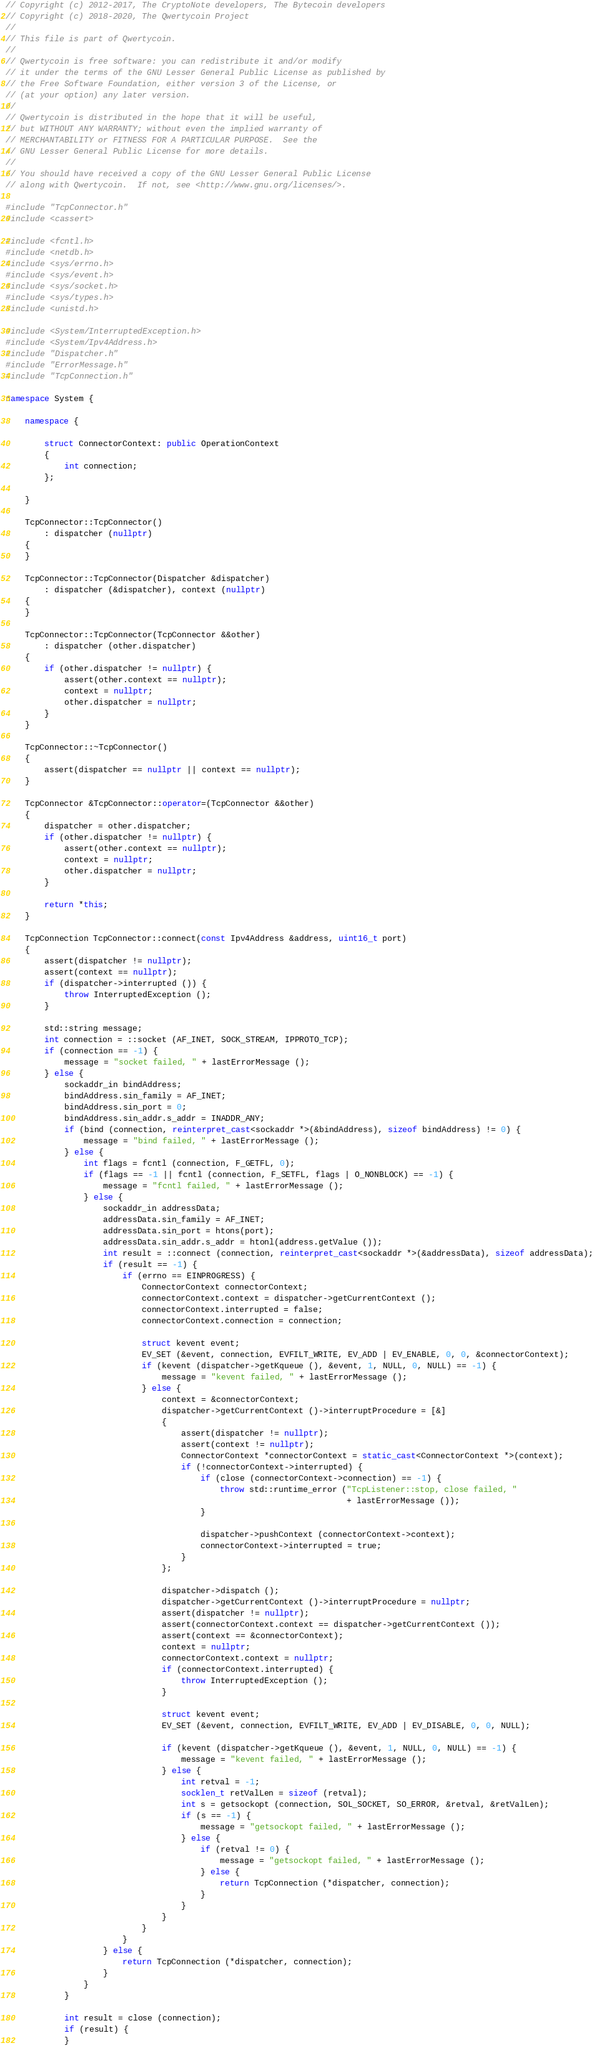<code> <loc_0><loc_0><loc_500><loc_500><_C++_>// Copyright (c) 2012-2017, The CryptoNote developers, The Bytecoin developers
// Copyright (c) 2018-2020, The Qwertycoin Project
//
// This file is part of Qwertycoin.
//
// Qwertycoin is free software: you can redistribute it and/or modify
// it under the terms of the GNU Lesser General Public License as published by
// the Free Software Foundation, either version 3 of the License, or
// (at your option) any later version.
//
// Qwertycoin is distributed in the hope that it will be useful,
// but WITHOUT ANY WARRANTY; without even the implied warranty of
// MERCHANTABILITY or FITNESS FOR A PARTICULAR PURPOSE.  See the
// GNU Lesser General Public License for more details.
//
// You should have received a copy of the GNU Lesser General Public License
// along with Qwertycoin.  If not, see <http://www.gnu.org/licenses/>.

#include "TcpConnector.h"
#include <cassert>

#include <fcntl.h>
#include <netdb.h>
#include <sys/errno.h>
#include <sys/event.h>
#include <sys/socket.h>
#include <sys/types.h>
#include <unistd.h>

#include <System/InterruptedException.h>
#include <System/Ipv4Address.h>
#include "Dispatcher.h"
#include "ErrorMessage.h"
#include "TcpConnection.h"

namespace System {

    namespace {

        struct ConnectorContext: public OperationContext
        {
            int connection;
        };

    }

    TcpConnector::TcpConnector()
        : dispatcher (nullptr)
    {
    }

    TcpConnector::TcpConnector(Dispatcher &dispatcher)
        : dispatcher (&dispatcher), context (nullptr)
    {
    }

    TcpConnector::TcpConnector(TcpConnector &&other)
        : dispatcher (other.dispatcher)
    {
        if (other.dispatcher != nullptr) {
            assert(other.context == nullptr);
            context = nullptr;
            other.dispatcher = nullptr;
        }
    }

    TcpConnector::~TcpConnector()
    {
        assert(dispatcher == nullptr || context == nullptr);
    }

    TcpConnector &TcpConnector::operator=(TcpConnector &&other)
    {
        dispatcher = other.dispatcher;
        if (other.dispatcher != nullptr) {
            assert(other.context == nullptr);
            context = nullptr;
            other.dispatcher = nullptr;
        }

        return *this;
    }

    TcpConnection TcpConnector::connect(const Ipv4Address &address, uint16_t port)
    {
        assert(dispatcher != nullptr);
        assert(context == nullptr);
        if (dispatcher->interrupted ()) {
            throw InterruptedException ();
        }

        std::string message;
        int connection = ::socket (AF_INET, SOCK_STREAM, IPPROTO_TCP);
        if (connection == -1) {
            message = "socket failed, " + lastErrorMessage ();
        } else {
            sockaddr_in bindAddress;
            bindAddress.sin_family = AF_INET;
            bindAddress.sin_port = 0;
            bindAddress.sin_addr.s_addr = INADDR_ANY;
            if (bind (connection, reinterpret_cast<sockaddr *>(&bindAddress), sizeof bindAddress) != 0) {
                message = "bind failed, " + lastErrorMessage ();
            } else {
                int flags = fcntl (connection, F_GETFL, 0);
                if (flags == -1 || fcntl (connection, F_SETFL, flags | O_NONBLOCK) == -1) {
                    message = "fcntl failed, " + lastErrorMessage ();
                } else {
                    sockaddr_in addressData;
                    addressData.sin_family = AF_INET;
                    addressData.sin_port = htons(port);
                    addressData.sin_addr.s_addr = htonl(address.getValue ());
                    int result = ::connect (connection, reinterpret_cast<sockaddr *>(&addressData), sizeof addressData);
                    if (result == -1) {
                        if (errno == EINPROGRESS) {
                            ConnectorContext connectorContext;
                            connectorContext.context = dispatcher->getCurrentContext ();
                            connectorContext.interrupted = false;
                            connectorContext.connection = connection;

                            struct kevent event;
                            EV_SET (&event, connection, EVFILT_WRITE, EV_ADD | EV_ENABLE, 0, 0, &connectorContext);
                            if (kevent (dispatcher->getKqueue (), &event, 1, NULL, 0, NULL) == -1) {
                                message = "kevent failed, " + lastErrorMessage ();
                            } else {
                                context = &connectorContext;
                                dispatcher->getCurrentContext ()->interruptProcedure = [&]
                                {
                                    assert(dispatcher != nullptr);
                                    assert(context != nullptr);
                                    ConnectorContext *connectorContext = static_cast<ConnectorContext *>(context);
                                    if (!connectorContext->interrupted) {
                                        if (close (connectorContext->connection) == -1) {
                                            throw std::runtime_error ("TcpListener::stop, close failed, "
                                                                      + lastErrorMessage ());
                                        }

                                        dispatcher->pushContext (connectorContext->context);
                                        connectorContext->interrupted = true;
                                    }
                                };

                                dispatcher->dispatch ();
                                dispatcher->getCurrentContext ()->interruptProcedure = nullptr;
                                assert(dispatcher != nullptr);
                                assert(connectorContext.context == dispatcher->getCurrentContext ());
                                assert(context == &connectorContext);
                                context = nullptr;
                                connectorContext.context = nullptr;
                                if (connectorContext.interrupted) {
                                    throw InterruptedException ();
                                }

                                struct kevent event;
                                EV_SET (&event, connection, EVFILT_WRITE, EV_ADD | EV_DISABLE, 0, 0, NULL);

                                if (kevent (dispatcher->getKqueue (), &event, 1, NULL, 0, NULL) == -1) {
                                    message = "kevent failed, " + lastErrorMessage ();
                                } else {
                                    int retval = -1;
                                    socklen_t retValLen = sizeof (retval);
                                    int s = getsockopt (connection, SOL_SOCKET, SO_ERROR, &retval, &retValLen);
                                    if (s == -1) {
                                        message = "getsockopt failed, " + lastErrorMessage ();
                                    } else {
                                        if (retval != 0) {
                                            message = "getsockopt failed, " + lastErrorMessage ();
                                        } else {
                                            return TcpConnection (*dispatcher, connection);
                                        }
                                    }
                                }
                            }
                        }
                    } else {
                        return TcpConnection (*dispatcher, connection);
                    }
                }
            }

            int result = close (connection);
            if (result) {
            }</code> 